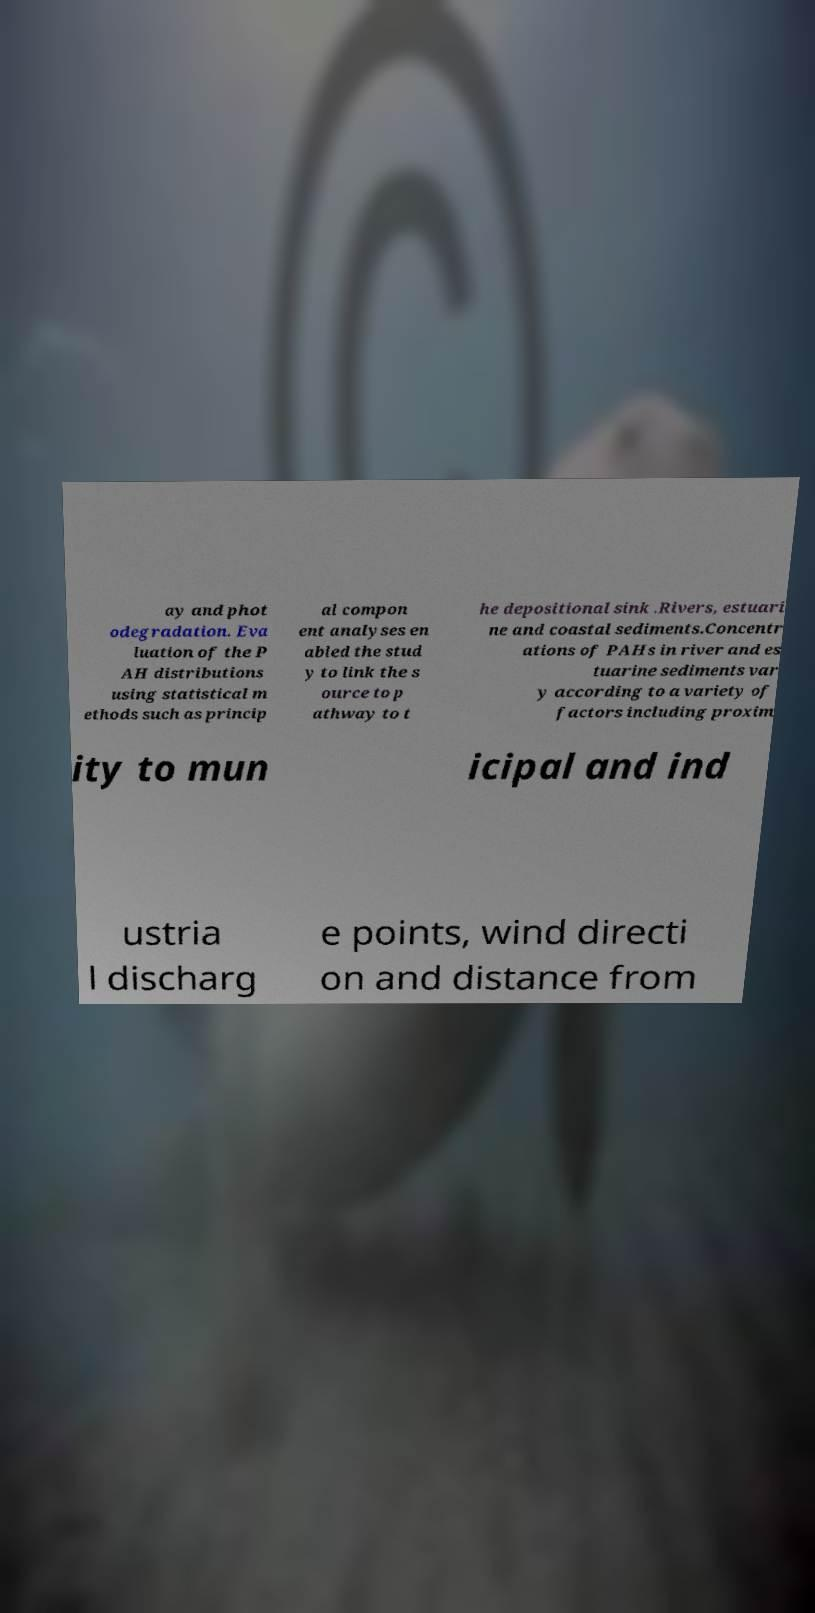Could you assist in decoding the text presented in this image and type it out clearly? ay and phot odegradation. Eva luation of the P AH distributions using statistical m ethods such as princip al compon ent analyses en abled the stud y to link the s ource to p athway to t he depositional sink .Rivers, estuari ne and coastal sediments.Concentr ations of PAHs in river and es tuarine sediments var y according to a variety of factors including proxim ity to mun icipal and ind ustria l discharg e points, wind directi on and distance from 